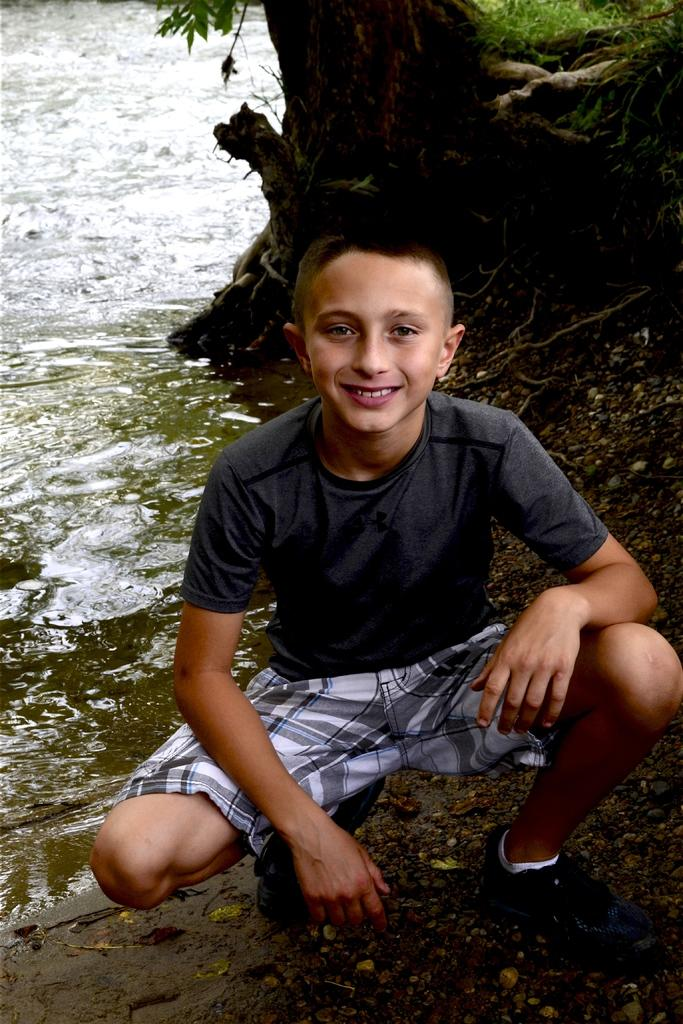Who or what is the main subject in the image? There is a person in the image. What is the person wearing? The person is wearing a black and white dress. What is the person doing in the image? The person is sitting. What can be seen in the background of the image? There is water and a tree visible in the background of the image. What type of cherry is being traded in the image? There is no mention of cherries or trading in the image; it features a person sitting in a black and white dress with a water and tree in the background. 